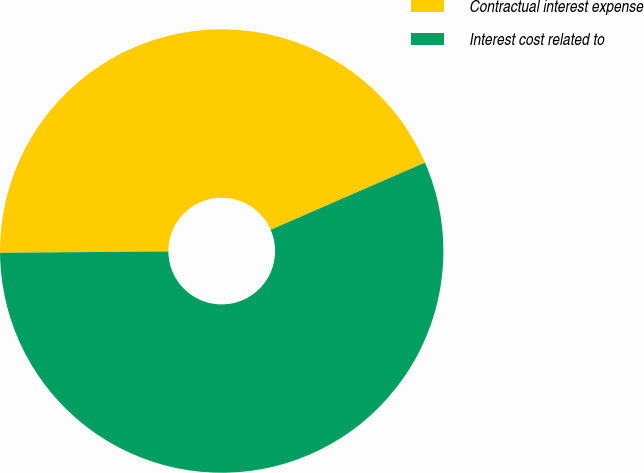Convert chart to OTSL. <chart><loc_0><loc_0><loc_500><loc_500><pie_chart><fcel>Contractual interest expense<fcel>Interest cost related to<nl><fcel>43.59%<fcel>56.41%<nl></chart> 